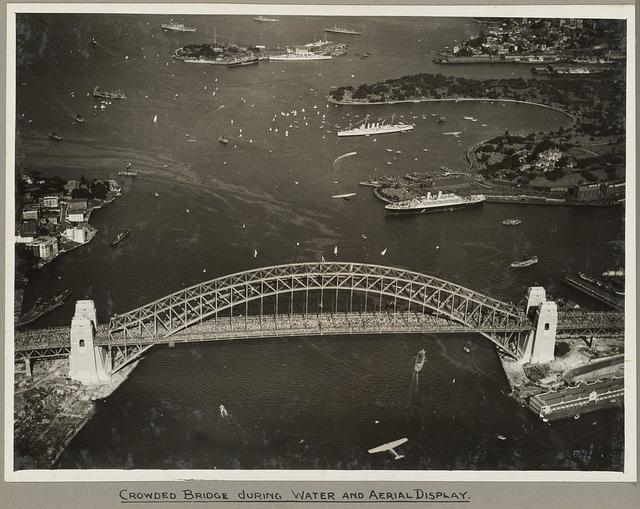Are there ships on the water?
Give a very brief answer. Yes. Is this photo annotated?
Write a very short answer. Yes. Can people walk on this bridge?
Concise answer only. Yes. 